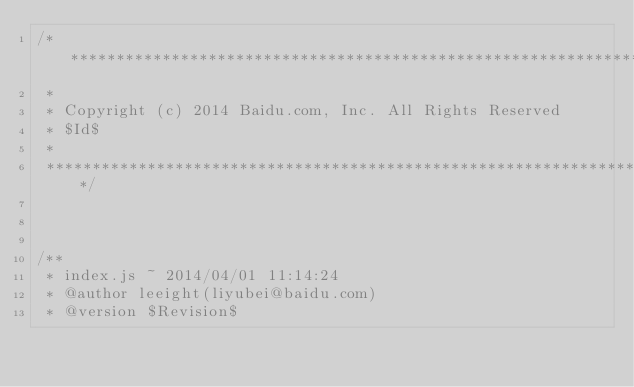<code> <loc_0><loc_0><loc_500><loc_500><_JavaScript_>/***************************************************************************
 * 
 * Copyright (c) 2014 Baidu.com, Inc. All Rights Reserved
 * $Id$ 
 * 
 **************************************************************************/
 
 
 
/**
 * index.js ~ 2014/04/01 11:14:24
 * @author leeight(liyubei@baidu.com)
 * @version $Revision$ </code> 